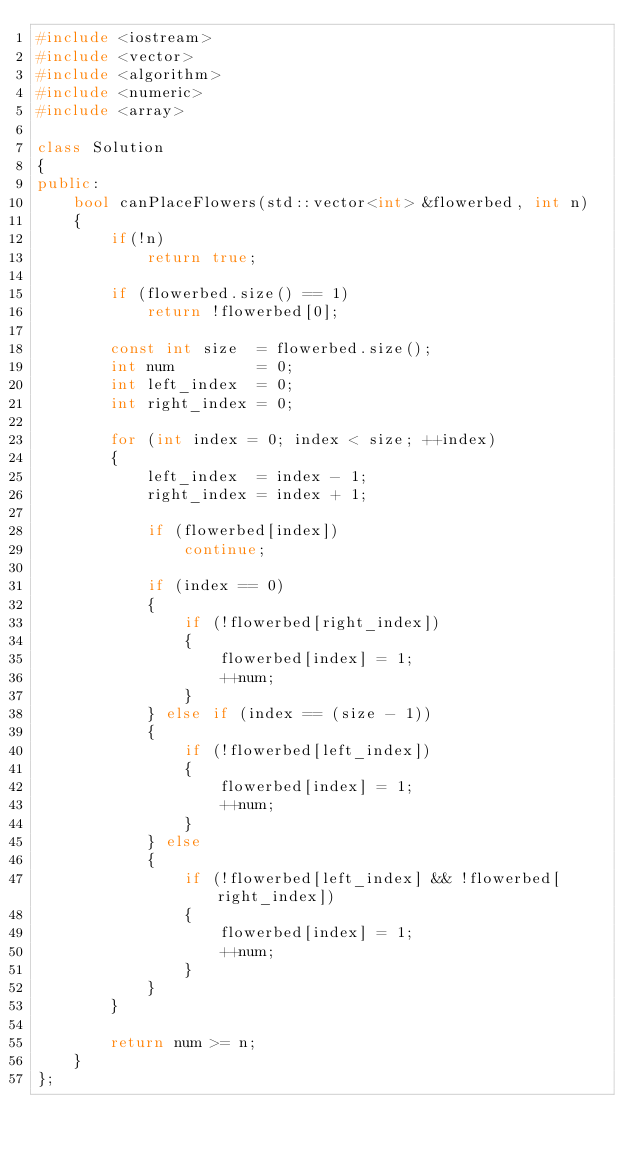<code> <loc_0><loc_0><loc_500><loc_500><_C++_>#include <iostream>
#include <vector>
#include <algorithm>
#include <numeric>
#include <array>

class Solution
{
public:
    bool canPlaceFlowers(std::vector<int> &flowerbed, int n)
    {
        if(!n)
            return true;

        if (flowerbed.size() == 1)
            return !flowerbed[0];

        const int size  = flowerbed.size();
        int num         = 0;
        int left_index  = 0;
        int right_index = 0;

        for (int index = 0; index < size; ++index)
        {
            left_index  = index - 1;
            right_index = index + 1;

            if (flowerbed[index])
                continue;

            if (index == 0)
            {
                if (!flowerbed[right_index])
                {
                    flowerbed[index] = 1;
                    ++num;
                }
            } else if (index == (size - 1))
            {
                if (!flowerbed[left_index])
                {
                    flowerbed[index] = 1;
                    ++num;
                }
            } else
            {
                if (!flowerbed[left_index] && !flowerbed[right_index])
                {
                    flowerbed[index] = 1;
                    ++num;
                }
            }
        }

        return num >= n;
    }
};
</code> 